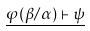<formula> <loc_0><loc_0><loc_500><loc_500>\underline { \varphi ( \beta / \alpha ) \vdash \psi }</formula> 